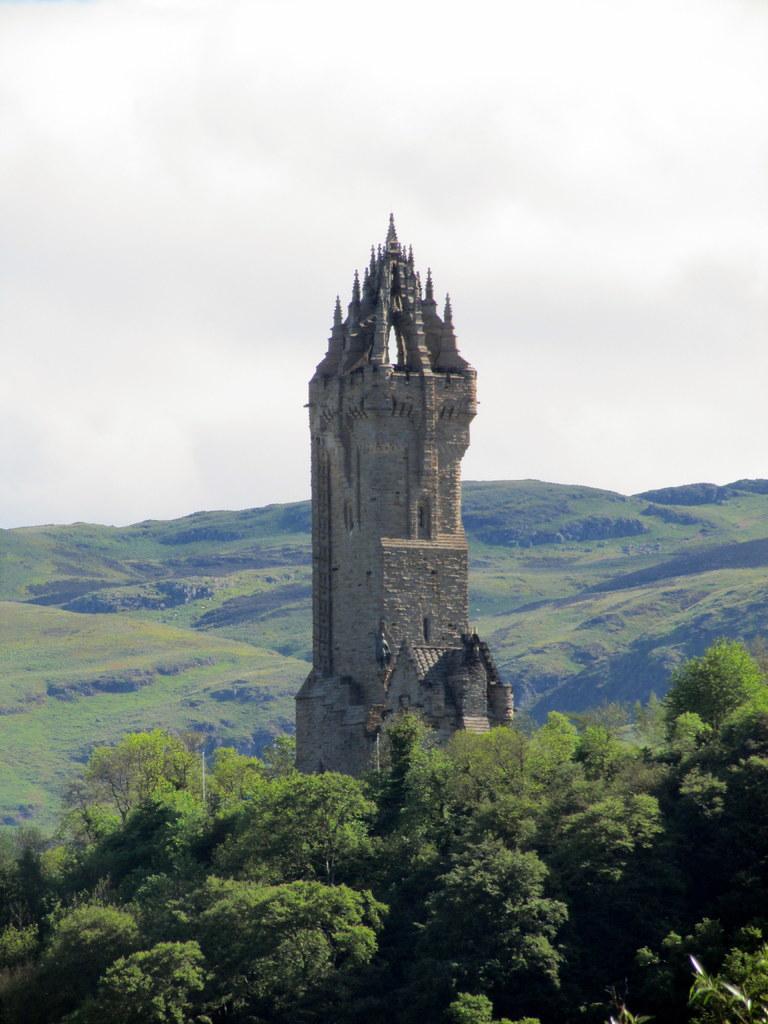Please provide a concise description of this image. In this image we can see the Wallace monument in the middle of the image, some mountains, some trees on the ground, some grass on the mountains and at the top there is the sky.  